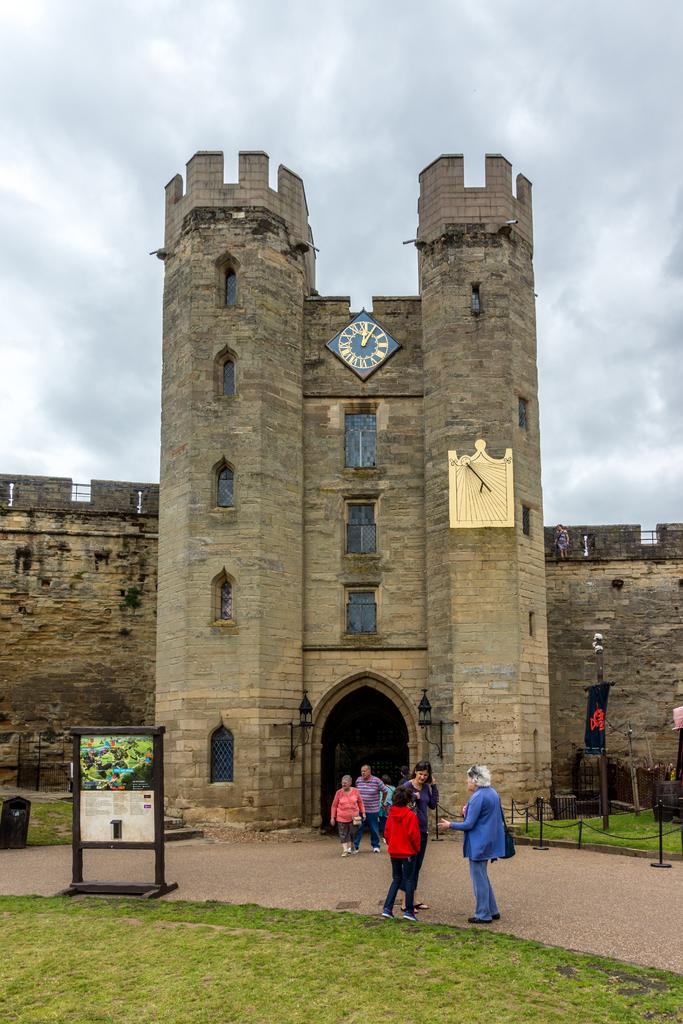What is the main structure in the picture? There is a building in the picture. Are there any people near the building? Yes, there are people in front of the building. What is placed in front of the building? There is a board in front of the building. What type of natural environment is visible in the image? There is grass visible in the image. What type of flesh can be seen hanging from the building in the image? There is no flesh visible in the image, and nothing is hanging from the building. 